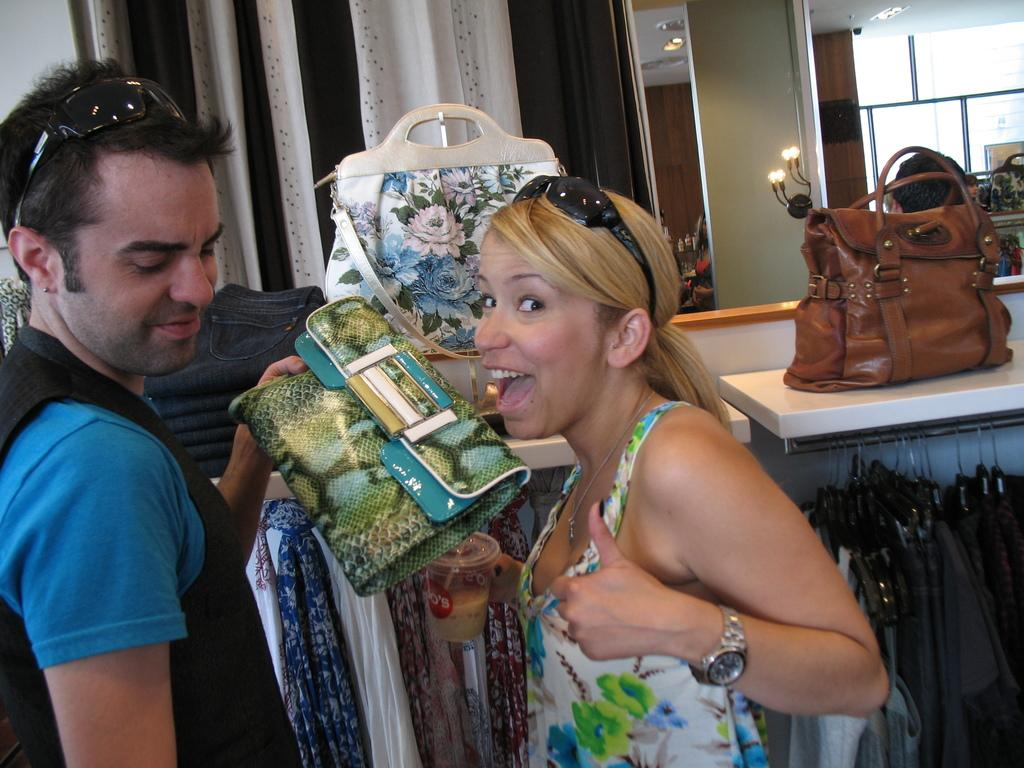How many people are in the image? There are two persons in the image. What are the persons doing in the image? The persons are standing and holding handbags. What is the facial expression of the persons in the image? The persons are smiling in the image. What can be seen in the background of the image? There is a curtain, a table, a handbag, a light, and clothes in the background of the image. Can you see any clouds in the image? There are no clouds visible in the image. What type of match is being played by the persons in the image? There is no match or game being played in the image; the persons are simply standing and holding handbags. 